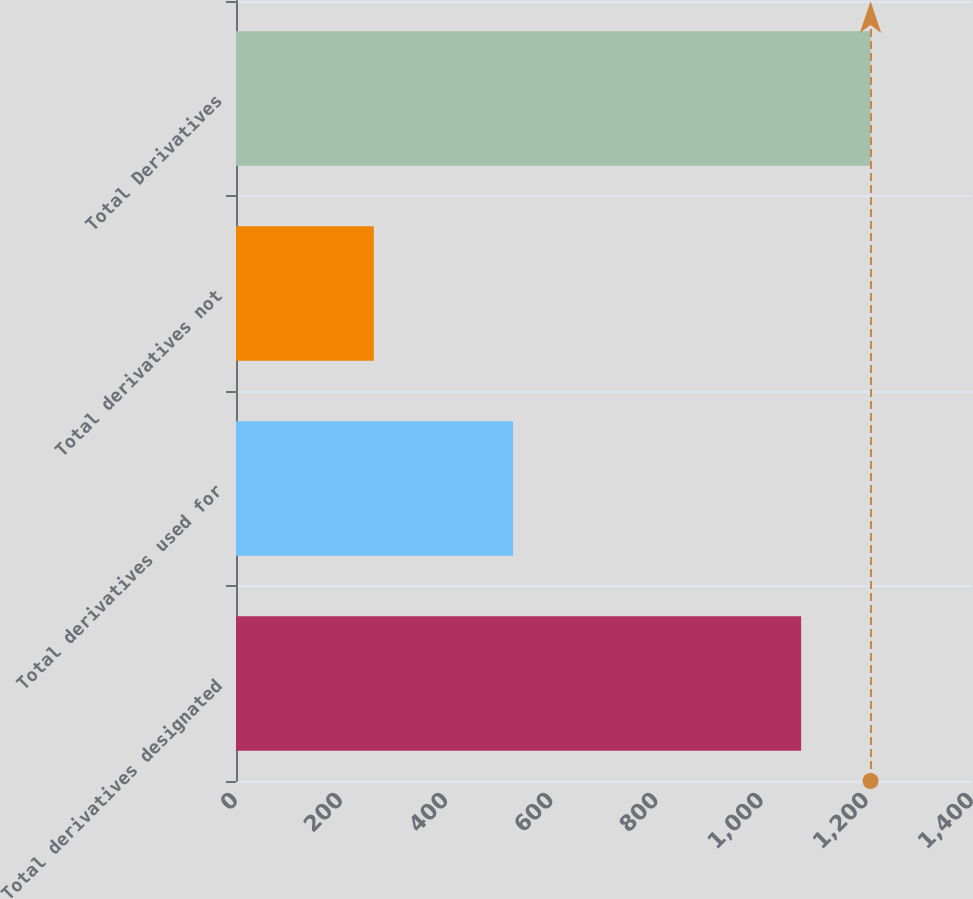Convert chart to OTSL. <chart><loc_0><loc_0><loc_500><loc_500><bar_chart><fcel>Total derivatives designated<fcel>Total derivatives used for<fcel>Total derivatives not<fcel>Total Derivatives<nl><fcel>1075<fcel>527.1<fcel>262.2<fcel>1207<nl></chart> 